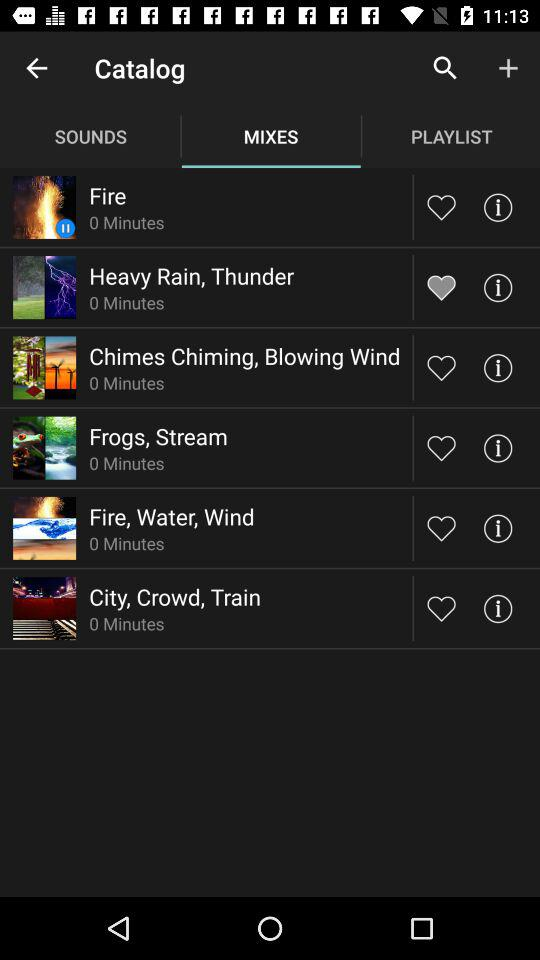How long does the "Frogs, Stream" last? The "Frogs, Stream" lasts for 0 minutes. 